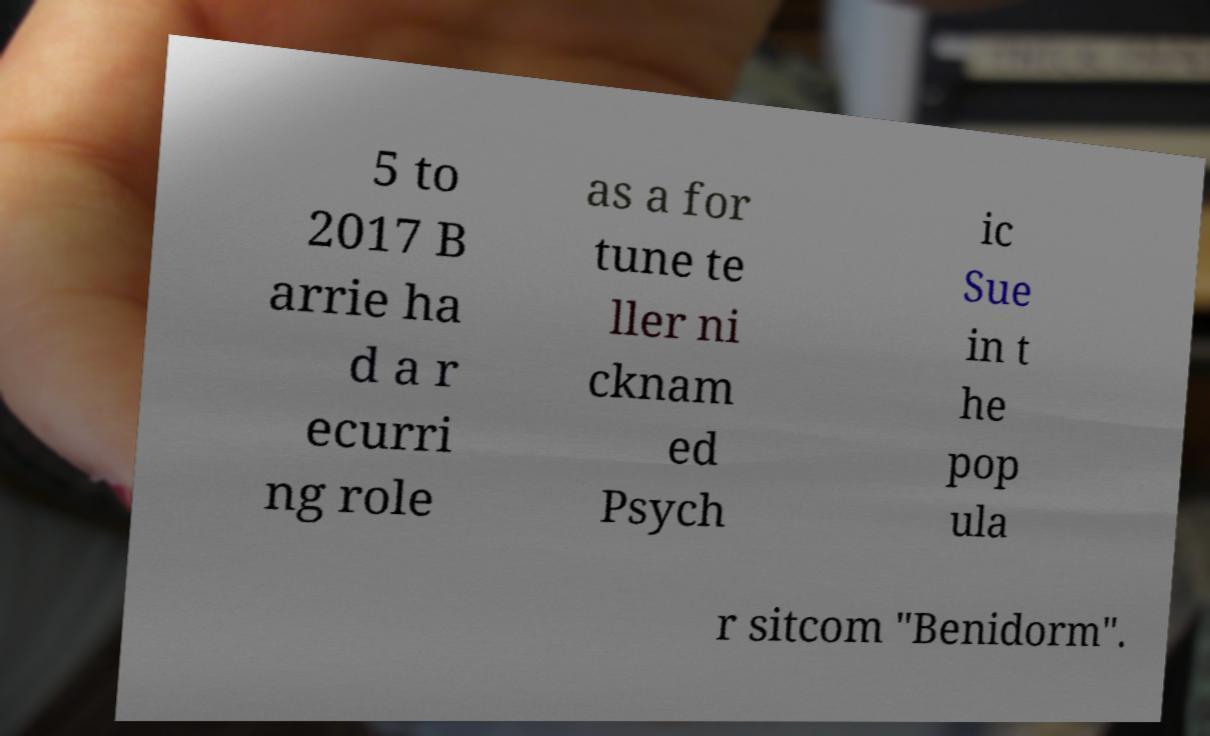Could you extract and type out the text from this image? 5 to 2017 B arrie ha d a r ecurri ng role as a for tune te ller ni cknam ed Psych ic Sue in t he pop ula r sitcom "Benidorm". 